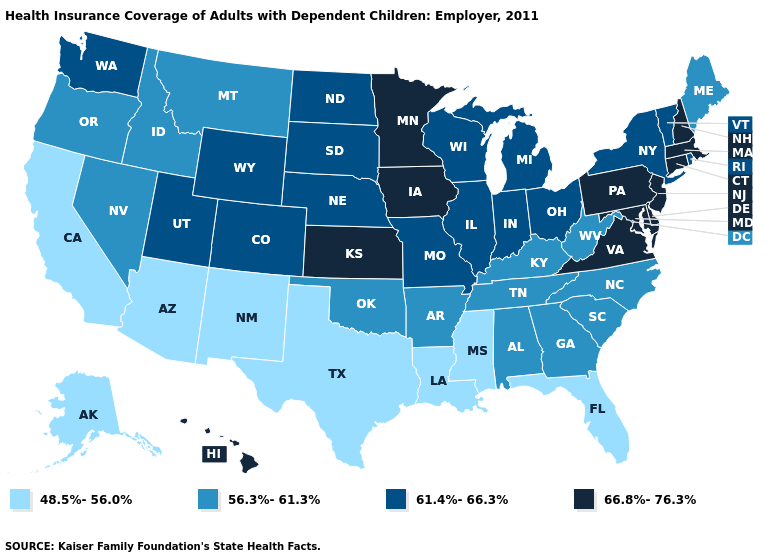Name the states that have a value in the range 66.8%-76.3%?
Concise answer only. Connecticut, Delaware, Hawaii, Iowa, Kansas, Maryland, Massachusetts, Minnesota, New Hampshire, New Jersey, Pennsylvania, Virginia. What is the value of Idaho?
Short answer required. 56.3%-61.3%. Does Oklahoma have a higher value than California?
Short answer required. Yes. What is the highest value in the South ?
Quick response, please. 66.8%-76.3%. Does Georgia have a lower value than Oregon?
Give a very brief answer. No. What is the value of Colorado?
Be succinct. 61.4%-66.3%. Name the states that have a value in the range 61.4%-66.3%?
Keep it brief. Colorado, Illinois, Indiana, Michigan, Missouri, Nebraska, New York, North Dakota, Ohio, Rhode Island, South Dakota, Utah, Vermont, Washington, Wisconsin, Wyoming. What is the lowest value in the USA?
Quick response, please. 48.5%-56.0%. What is the highest value in the MidWest ?
Answer briefly. 66.8%-76.3%. Is the legend a continuous bar?
Quick response, please. No. Does North Dakota have the highest value in the MidWest?
Keep it brief. No. What is the value of North Dakota?
Quick response, please. 61.4%-66.3%. Name the states that have a value in the range 56.3%-61.3%?
Give a very brief answer. Alabama, Arkansas, Georgia, Idaho, Kentucky, Maine, Montana, Nevada, North Carolina, Oklahoma, Oregon, South Carolina, Tennessee, West Virginia. Does Idaho have the lowest value in the USA?
Answer briefly. No. Name the states that have a value in the range 48.5%-56.0%?
Answer briefly. Alaska, Arizona, California, Florida, Louisiana, Mississippi, New Mexico, Texas. 